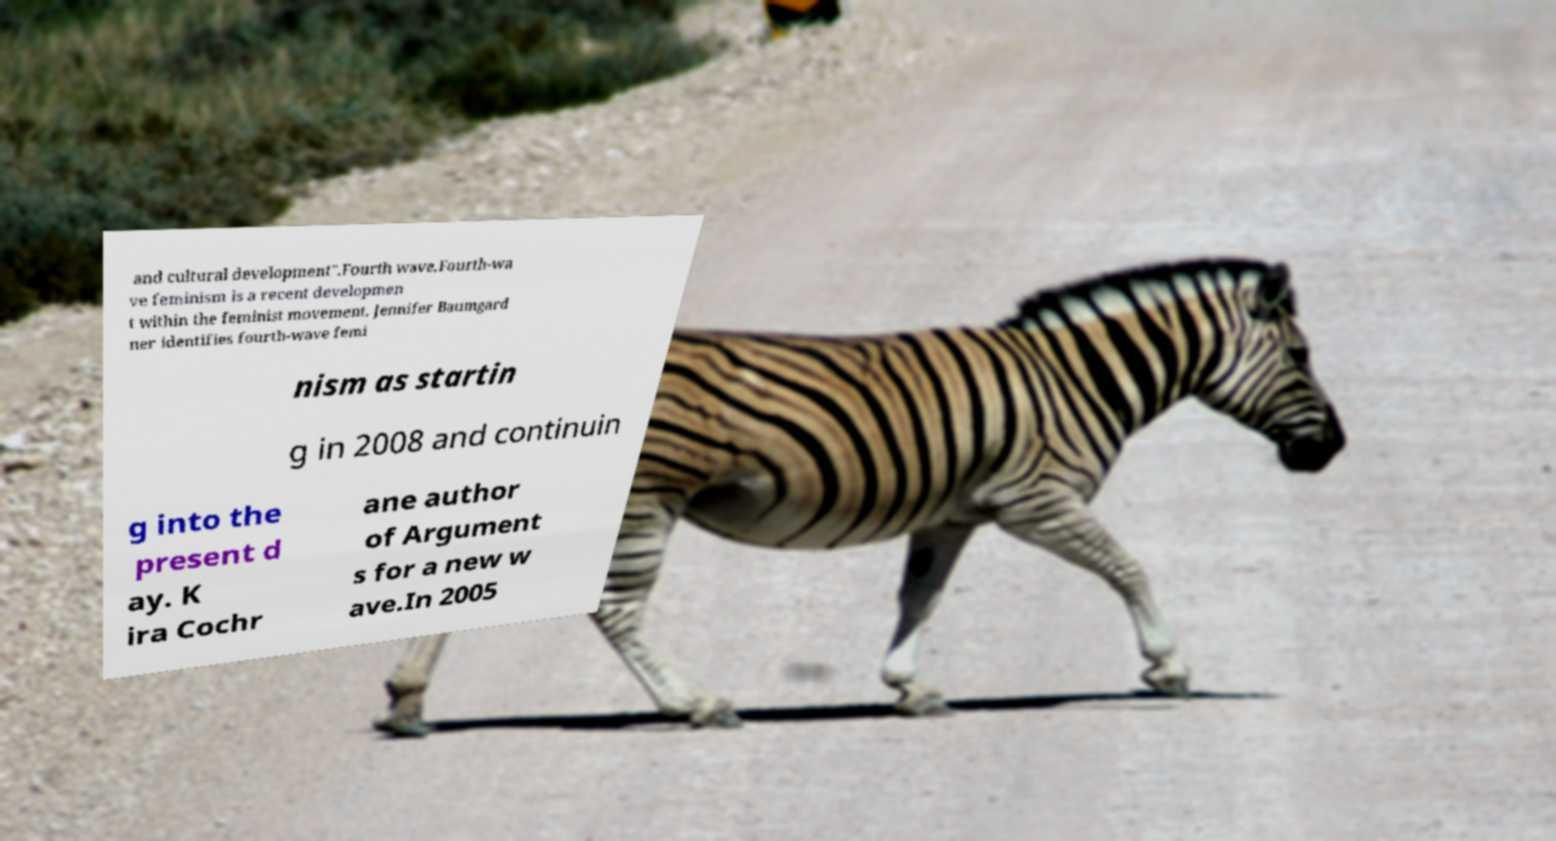For documentation purposes, I need the text within this image transcribed. Could you provide that? and cultural development".Fourth wave.Fourth-wa ve feminism is a recent developmen t within the feminist movement. Jennifer Baumgard ner identifies fourth-wave femi nism as startin g in 2008 and continuin g into the present d ay. K ira Cochr ane author of Argument s for a new w ave.In 2005 